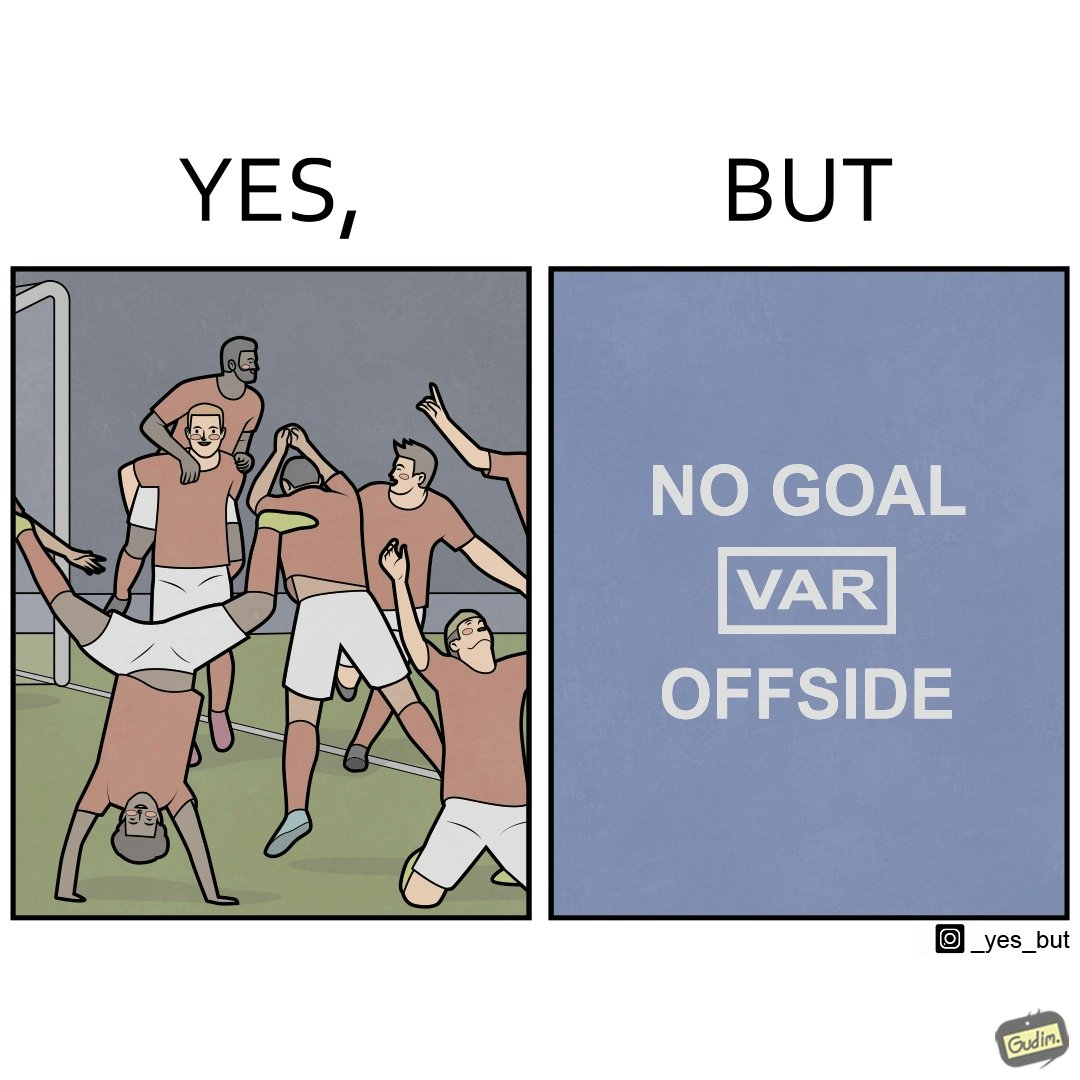Describe what you see in this image. The image is ironical, as the team is celebrating as they think that they have scored a goal, but the sign on the screen says that it is an offside, and not a goal. This is a very common scenario in football matches. 